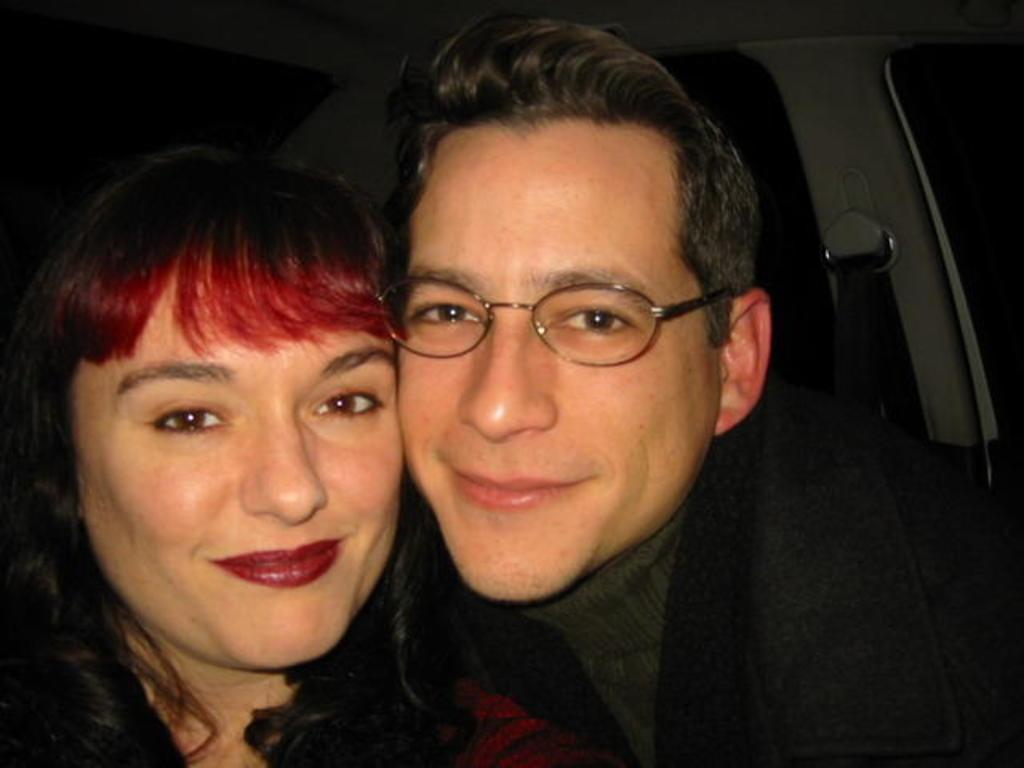Who is present in the image? There is a woman and a man in the image. What are the expressions on their faces? Both the woman and the man are smiling. Where was the image taken? The image appears to be taken inside a vehicle. What can be observed about the man's appearance? The man is wearing spectacles. What type of alarm can be heard going off in the image? There is no alarm present in the image, and therefore no such sound can be heard. 